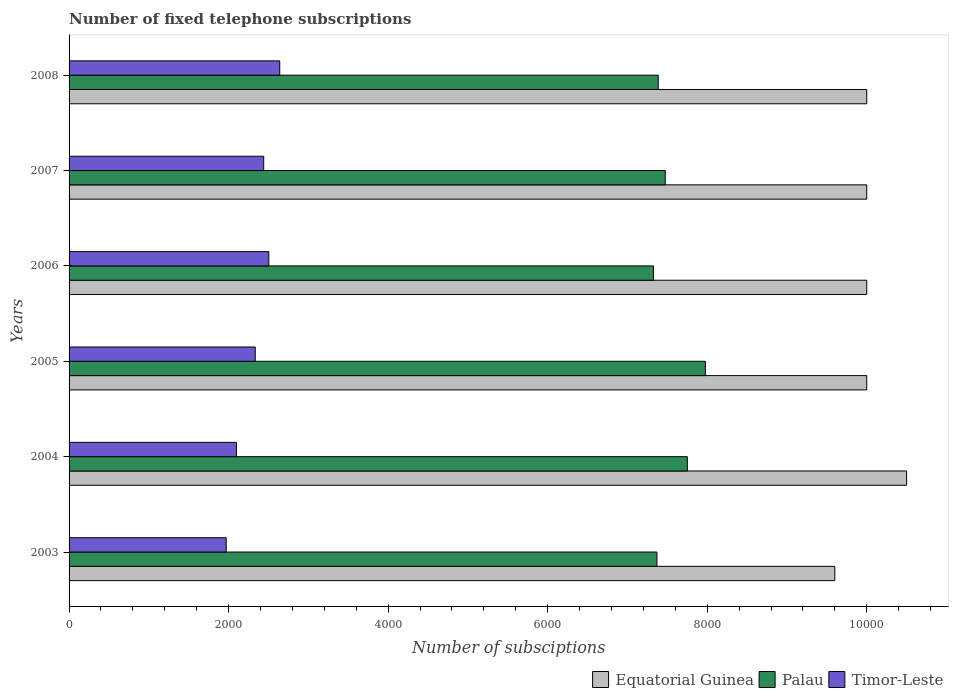How many different coloured bars are there?
Provide a succinct answer. 3. Are the number of bars per tick equal to the number of legend labels?
Your answer should be compact. Yes. Are the number of bars on each tick of the Y-axis equal?
Provide a short and direct response. Yes. How many bars are there on the 4th tick from the top?
Offer a very short reply. 3. What is the label of the 5th group of bars from the top?
Keep it short and to the point. 2004. In how many cases, is the number of bars for a given year not equal to the number of legend labels?
Your response must be concise. 0. What is the number of fixed telephone subscriptions in Equatorial Guinea in 2004?
Your answer should be very brief. 1.05e+04. Across all years, what is the maximum number of fixed telephone subscriptions in Palau?
Offer a terse response. 7977. Across all years, what is the minimum number of fixed telephone subscriptions in Timor-Leste?
Ensure brevity in your answer.  1970. What is the total number of fixed telephone subscriptions in Timor-Leste in the graph?
Your answer should be very brief. 1.40e+04. What is the difference between the number of fixed telephone subscriptions in Equatorial Guinea in 2007 and that in 2008?
Provide a succinct answer. 0. What is the difference between the number of fixed telephone subscriptions in Timor-Leste in 2006 and the number of fixed telephone subscriptions in Equatorial Guinea in 2007?
Your answer should be compact. -7496. What is the average number of fixed telephone subscriptions in Equatorial Guinea per year?
Offer a very short reply. 1.00e+04. In the year 2003, what is the difference between the number of fixed telephone subscriptions in Equatorial Guinea and number of fixed telephone subscriptions in Timor-Leste?
Offer a terse response. 7630. In how many years, is the number of fixed telephone subscriptions in Equatorial Guinea greater than 7600 ?
Your answer should be compact. 6. What is the difference between the highest and the second highest number of fixed telephone subscriptions in Palau?
Offer a terse response. 226. What is the difference between the highest and the lowest number of fixed telephone subscriptions in Timor-Leste?
Provide a succinct answer. 671. What does the 2nd bar from the top in 2006 represents?
Your answer should be very brief. Palau. What does the 3rd bar from the bottom in 2005 represents?
Your answer should be very brief. Timor-Leste. Is it the case that in every year, the sum of the number of fixed telephone subscriptions in Palau and number of fixed telephone subscriptions in Equatorial Guinea is greater than the number of fixed telephone subscriptions in Timor-Leste?
Make the answer very short. Yes. Are all the bars in the graph horizontal?
Provide a short and direct response. Yes. What is the difference between two consecutive major ticks on the X-axis?
Your answer should be very brief. 2000. Are the values on the major ticks of X-axis written in scientific E-notation?
Give a very brief answer. No. Does the graph contain any zero values?
Provide a succinct answer. No. How many legend labels are there?
Keep it short and to the point. 3. How are the legend labels stacked?
Your response must be concise. Horizontal. What is the title of the graph?
Offer a terse response. Number of fixed telephone subscriptions. What is the label or title of the X-axis?
Keep it short and to the point. Number of subsciptions. What is the label or title of the Y-axis?
Provide a succinct answer. Years. What is the Number of subsciptions of Equatorial Guinea in 2003?
Keep it short and to the point. 9600. What is the Number of subsciptions in Palau in 2003?
Give a very brief answer. 7370. What is the Number of subsciptions in Timor-Leste in 2003?
Provide a succinct answer. 1970. What is the Number of subsciptions of Equatorial Guinea in 2004?
Provide a short and direct response. 1.05e+04. What is the Number of subsciptions in Palau in 2004?
Offer a terse response. 7751. What is the Number of subsciptions in Timor-Leste in 2004?
Provide a succinct answer. 2098. What is the Number of subsciptions of Equatorial Guinea in 2005?
Your answer should be very brief. 10000. What is the Number of subsciptions in Palau in 2005?
Offer a very short reply. 7977. What is the Number of subsciptions of Timor-Leste in 2005?
Provide a succinct answer. 2334. What is the Number of subsciptions in Equatorial Guinea in 2006?
Ensure brevity in your answer.  10000. What is the Number of subsciptions of Palau in 2006?
Offer a very short reply. 7326. What is the Number of subsciptions of Timor-Leste in 2006?
Provide a succinct answer. 2504. What is the Number of subsciptions of Palau in 2007?
Your response must be concise. 7474. What is the Number of subsciptions of Timor-Leste in 2007?
Your answer should be very brief. 2440. What is the Number of subsciptions of Equatorial Guinea in 2008?
Provide a short and direct response. 10000. What is the Number of subsciptions in Palau in 2008?
Offer a terse response. 7386. What is the Number of subsciptions of Timor-Leste in 2008?
Your answer should be very brief. 2641. Across all years, what is the maximum Number of subsciptions of Equatorial Guinea?
Make the answer very short. 1.05e+04. Across all years, what is the maximum Number of subsciptions of Palau?
Make the answer very short. 7977. Across all years, what is the maximum Number of subsciptions of Timor-Leste?
Ensure brevity in your answer.  2641. Across all years, what is the minimum Number of subsciptions in Equatorial Guinea?
Provide a short and direct response. 9600. Across all years, what is the minimum Number of subsciptions of Palau?
Offer a very short reply. 7326. Across all years, what is the minimum Number of subsciptions of Timor-Leste?
Ensure brevity in your answer.  1970. What is the total Number of subsciptions of Equatorial Guinea in the graph?
Offer a terse response. 6.01e+04. What is the total Number of subsciptions in Palau in the graph?
Your response must be concise. 4.53e+04. What is the total Number of subsciptions in Timor-Leste in the graph?
Offer a very short reply. 1.40e+04. What is the difference between the Number of subsciptions in Equatorial Guinea in 2003 and that in 2004?
Your response must be concise. -900. What is the difference between the Number of subsciptions in Palau in 2003 and that in 2004?
Provide a succinct answer. -381. What is the difference between the Number of subsciptions of Timor-Leste in 2003 and that in 2004?
Your answer should be compact. -128. What is the difference between the Number of subsciptions of Equatorial Guinea in 2003 and that in 2005?
Give a very brief answer. -400. What is the difference between the Number of subsciptions of Palau in 2003 and that in 2005?
Offer a terse response. -607. What is the difference between the Number of subsciptions of Timor-Leste in 2003 and that in 2005?
Provide a short and direct response. -364. What is the difference between the Number of subsciptions in Equatorial Guinea in 2003 and that in 2006?
Give a very brief answer. -400. What is the difference between the Number of subsciptions of Palau in 2003 and that in 2006?
Offer a terse response. 44. What is the difference between the Number of subsciptions of Timor-Leste in 2003 and that in 2006?
Your answer should be compact. -534. What is the difference between the Number of subsciptions of Equatorial Guinea in 2003 and that in 2007?
Ensure brevity in your answer.  -400. What is the difference between the Number of subsciptions of Palau in 2003 and that in 2007?
Offer a very short reply. -104. What is the difference between the Number of subsciptions of Timor-Leste in 2003 and that in 2007?
Keep it short and to the point. -470. What is the difference between the Number of subsciptions of Equatorial Guinea in 2003 and that in 2008?
Keep it short and to the point. -400. What is the difference between the Number of subsciptions of Timor-Leste in 2003 and that in 2008?
Your answer should be compact. -671. What is the difference between the Number of subsciptions of Equatorial Guinea in 2004 and that in 2005?
Give a very brief answer. 500. What is the difference between the Number of subsciptions of Palau in 2004 and that in 2005?
Your answer should be compact. -226. What is the difference between the Number of subsciptions in Timor-Leste in 2004 and that in 2005?
Provide a short and direct response. -236. What is the difference between the Number of subsciptions in Palau in 2004 and that in 2006?
Ensure brevity in your answer.  425. What is the difference between the Number of subsciptions of Timor-Leste in 2004 and that in 2006?
Provide a short and direct response. -406. What is the difference between the Number of subsciptions of Equatorial Guinea in 2004 and that in 2007?
Give a very brief answer. 500. What is the difference between the Number of subsciptions in Palau in 2004 and that in 2007?
Make the answer very short. 277. What is the difference between the Number of subsciptions in Timor-Leste in 2004 and that in 2007?
Offer a very short reply. -342. What is the difference between the Number of subsciptions in Equatorial Guinea in 2004 and that in 2008?
Provide a short and direct response. 500. What is the difference between the Number of subsciptions of Palau in 2004 and that in 2008?
Your answer should be compact. 365. What is the difference between the Number of subsciptions in Timor-Leste in 2004 and that in 2008?
Provide a succinct answer. -543. What is the difference between the Number of subsciptions in Equatorial Guinea in 2005 and that in 2006?
Provide a succinct answer. 0. What is the difference between the Number of subsciptions of Palau in 2005 and that in 2006?
Make the answer very short. 651. What is the difference between the Number of subsciptions in Timor-Leste in 2005 and that in 2006?
Provide a succinct answer. -170. What is the difference between the Number of subsciptions in Equatorial Guinea in 2005 and that in 2007?
Your answer should be very brief. 0. What is the difference between the Number of subsciptions in Palau in 2005 and that in 2007?
Your answer should be compact. 503. What is the difference between the Number of subsciptions of Timor-Leste in 2005 and that in 2007?
Offer a terse response. -106. What is the difference between the Number of subsciptions of Equatorial Guinea in 2005 and that in 2008?
Keep it short and to the point. 0. What is the difference between the Number of subsciptions of Palau in 2005 and that in 2008?
Give a very brief answer. 591. What is the difference between the Number of subsciptions of Timor-Leste in 2005 and that in 2008?
Make the answer very short. -307. What is the difference between the Number of subsciptions of Palau in 2006 and that in 2007?
Provide a succinct answer. -148. What is the difference between the Number of subsciptions in Timor-Leste in 2006 and that in 2007?
Your answer should be compact. 64. What is the difference between the Number of subsciptions of Equatorial Guinea in 2006 and that in 2008?
Make the answer very short. 0. What is the difference between the Number of subsciptions of Palau in 2006 and that in 2008?
Make the answer very short. -60. What is the difference between the Number of subsciptions of Timor-Leste in 2006 and that in 2008?
Offer a terse response. -137. What is the difference between the Number of subsciptions in Timor-Leste in 2007 and that in 2008?
Ensure brevity in your answer.  -201. What is the difference between the Number of subsciptions of Equatorial Guinea in 2003 and the Number of subsciptions of Palau in 2004?
Provide a short and direct response. 1849. What is the difference between the Number of subsciptions of Equatorial Guinea in 2003 and the Number of subsciptions of Timor-Leste in 2004?
Your answer should be compact. 7502. What is the difference between the Number of subsciptions in Palau in 2003 and the Number of subsciptions in Timor-Leste in 2004?
Keep it short and to the point. 5272. What is the difference between the Number of subsciptions in Equatorial Guinea in 2003 and the Number of subsciptions in Palau in 2005?
Make the answer very short. 1623. What is the difference between the Number of subsciptions of Equatorial Guinea in 2003 and the Number of subsciptions of Timor-Leste in 2005?
Your answer should be compact. 7266. What is the difference between the Number of subsciptions in Palau in 2003 and the Number of subsciptions in Timor-Leste in 2005?
Keep it short and to the point. 5036. What is the difference between the Number of subsciptions of Equatorial Guinea in 2003 and the Number of subsciptions of Palau in 2006?
Your response must be concise. 2274. What is the difference between the Number of subsciptions of Equatorial Guinea in 2003 and the Number of subsciptions of Timor-Leste in 2006?
Your answer should be compact. 7096. What is the difference between the Number of subsciptions of Palau in 2003 and the Number of subsciptions of Timor-Leste in 2006?
Your response must be concise. 4866. What is the difference between the Number of subsciptions of Equatorial Guinea in 2003 and the Number of subsciptions of Palau in 2007?
Provide a succinct answer. 2126. What is the difference between the Number of subsciptions in Equatorial Guinea in 2003 and the Number of subsciptions in Timor-Leste in 2007?
Keep it short and to the point. 7160. What is the difference between the Number of subsciptions in Palau in 2003 and the Number of subsciptions in Timor-Leste in 2007?
Your answer should be very brief. 4930. What is the difference between the Number of subsciptions of Equatorial Guinea in 2003 and the Number of subsciptions of Palau in 2008?
Offer a very short reply. 2214. What is the difference between the Number of subsciptions of Equatorial Guinea in 2003 and the Number of subsciptions of Timor-Leste in 2008?
Your answer should be very brief. 6959. What is the difference between the Number of subsciptions in Palau in 2003 and the Number of subsciptions in Timor-Leste in 2008?
Your answer should be very brief. 4729. What is the difference between the Number of subsciptions of Equatorial Guinea in 2004 and the Number of subsciptions of Palau in 2005?
Your answer should be very brief. 2523. What is the difference between the Number of subsciptions in Equatorial Guinea in 2004 and the Number of subsciptions in Timor-Leste in 2005?
Your answer should be compact. 8166. What is the difference between the Number of subsciptions in Palau in 2004 and the Number of subsciptions in Timor-Leste in 2005?
Provide a succinct answer. 5417. What is the difference between the Number of subsciptions in Equatorial Guinea in 2004 and the Number of subsciptions in Palau in 2006?
Offer a very short reply. 3174. What is the difference between the Number of subsciptions of Equatorial Guinea in 2004 and the Number of subsciptions of Timor-Leste in 2006?
Make the answer very short. 7996. What is the difference between the Number of subsciptions in Palau in 2004 and the Number of subsciptions in Timor-Leste in 2006?
Make the answer very short. 5247. What is the difference between the Number of subsciptions in Equatorial Guinea in 2004 and the Number of subsciptions in Palau in 2007?
Provide a short and direct response. 3026. What is the difference between the Number of subsciptions in Equatorial Guinea in 2004 and the Number of subsciptions in Timor-Leste in 2007?
Provide a succinct answer. 8060. What is the difference between the Number of subsciptions in Palau in 2004 and the Number of subsciptions in Timor-Leste in 2007?
Your response must be concise. 5311. What is the difference between the Number of subsciptions in Equatorial Guinea in 2004 and the Number of subsciptions in Palau in 2008?
Your answer should be compact. 3114. What is the difference between the Number of subsciptions in Equatorial Guinea in 2004 and the Number of subsciptions in Timor-Leste in 2008?
Give a very brief answer. 7859. What is the difference between the Number of subsciptions of Palau in 2004 and the Number of subsciptions of Timor-Leste in 2008?
Ensure brevity in your answer.  5110. What is the difference between the Number of subsciptions in Equatorial Guinea in 2005 and the Number of subsciptions in Palau in 2006?
Keep it short and to the point. 2674. What is the difference between the Number of subsciptions of Equatorial Guinea in 2005 and the Number of subsciptions of Timor-Leste in 2006?
Provide a short and direct response. 7496. What is the difference between the Number of subsciptions in Palau in 2005 and the Number of subsciptions in Timor-Leste in 2006?
Ensure brevity in your answer.  5473. What is the difference between the Number of subsciptions in Equatorial Guinea in 2005 and the Number of subsciptions in Palau in 2007?
Your answer should be very brief. 2526. What is the difference between the Number of subsciptions of Equatorial Guinea in 2005 and the Number of subsciptions of Timor-Leste in 2007?
Your answer should be compact. 7560. What is the difference between the Number of subsciptions of Palau in 2005 and the Number of subsciptions of Timor-Leste in 2007?
Make the answer very short. 5537. What is the difference between the Number of subsciptions in Equatorial Guinea in 2005 and the Number of subsciptions in Palau in 2008?
Give a very brief answer. 2614. What is the difference between the Number of subsciptions of Equatorial Guinea in 2005 and the Number of subsciptions of Timor-Leste in 2008?
Provide a short and direct response. 7359. What is the difference between the Number of subsciptions in Palau in 2005 and the Number of subsciptions in Timor-Leste in 2008?
Ensure brevity in your answer.  5336. What is the difference between the Number of subsciptions of Equatorial Guinea in 2006 and the Number of subsciptions of Palau in 2007?
Make the answer very short. 2526. What is the difference between the Number of subsciptions in Equatorial Guinea in 2006 and the Number of subsciptions in Timor-Leste in 2007?
Your answer should be very brief. 7560. What is the difference between the Number of subsciptions of Palau in 2006 and the Number of subsciptions of Timor-Leste in 2007?
Offer a terse response. 4886. What is the difference between the Number of subsciptions of Equatorial Guinea in 2006 and the Number of subsciptions of Palau in 2008?
Give a very brief answer. 2614. What is the difference between the Number of subsciptions in Equatorial Guinea in 2006 and the Number of subsciptions in Timor-Leste in 2008?
Keep it short and to the point. 7359. What is the difference between the Number of subsciptions of Palau in 2006 and the Number of subsciptions of Timor-Leste in 2008?
Offer a very short reply. 4685. What is the difference between the Number of subsciptions in Equatorial Guinea in 2007 and the Number of subsciptions in Palau in 2008?
Give a very brief answer. 2614. What is the difference between the Number of subsciptions in Equatorial Guinea in 2007 and the Number of subsciptions in Timor-Leste in 2008?
Offer a terse response. 7359. What is the difference between the Number of subsciptions of Palau in 2007 and the Number of subsciptions of Timor-Leste in 2008?
Provide a short and direct response. 4833. What is the average Number of subsciptions in Equatorial Guinea per year?
Offer a very short reply. 1.00e+04. What is the average Number of subsciptions in Palau per year?
Your response must be concise. 7547.33. What is the average Number of subsciptions in Timor-Leste per year?
Your answer should be very brief. 2331.17. In the year 2003, what is the difference between the Number of subsciptions in Equatorial Guinea and Number of subsciptions in Palau?
Your answer should be compact. 2230. In the year 2003, what is the difference between the Number of subsciptions in Equatorial Guinea and Number of subsciptions in Timor-Leste?
Your answer should be very brief. 7630. In the year 2003, what is the difference between the Number of subsciptions of Palau and Number of subsciptions of Timor-Leste?
Your answer should be compact. 5400. In the year 2004, what is the difference between the Number of subsciptions of Equatorial Guinea and Number of subsciptions of Palau?
Your response must be concise. 2749. In the year 2004, what is the difference between the Number of subsciptions of Equatorial Guinea and Number of subsciptions of Timor-Leste?
Your answer should be very brief. 8402. In the year 2004, what is the difference between the Number of subsciptions of Palau and Number of subsciptions of Timor-Leste?
Offer a terse response. 5653. In the year 2005, what is the difference between the Number of subsciptions in Equatorial Guinea and Number of subsciptions in Palau?
Ensure brevity in your answer.  2023. In the year 2005, what is the difference between the Number of subsciptions of Equatorial Guinea and Number of subsciptions of Timor-Leste?
Your response must be concise. 7666. In the year 2005, what is the difference between the Number of subsciptions in Palau and Number of subsciptions in Timor-Leste?
Ensure brevity in your answer.  5643. In the year 2006, what is the difference between the Number of subsciptions in Equatorial Guinea and Number of subsciptions in Palau?
Your answer should be very brief. 2674. In the year 2006, what is the difference between the Number of subsciptions of Equatorial Guinea and Number of subsciptions of Timor-Leste?
Your response must be concise. 7496. In the year 2006, what is the difference between the Number of subsciptions in Palau and Number of subsciptions in Timor-Leste?
Keep it short and to the point. 4822. In the year 2007, what is the difference between the Number of subsciptions in Equatorial Guinea and Number of subsciptions in Palau?
Keep it short and to the point. 2526. In the year 2007, what is the difference between the Number of subsciptions in Equatorial Guinea and Number of subsciptions in Timor-Leste?
Provide a short and direct response. 7560. In the year 2007, what is the difference between the Number of subsciptions of Palau and Number of subsciptions of Timor-Leste?
Your answer should be very brief. 5034. In the year 2008, what is the difference between the Number of subsciptions in Equatorial Guinea and Number of subsciptions in Palau?
Offer a very short reply. 2614. In the year 2008, what is the difference between the Number of subsciptions in Equatorial Guinea and Number of subsciptions in Timor-Leste?
Keep it short and to the point. 7359. In the year 2008, what is the difference between the Number of subsciptions in Palau and Number of subsciptions in Timor-Leste?
Make the answer very short. 4745. What is the ratio of the Number of subsciptions of Equatorial Guinea in 2003 to that in 2004?
Make the answer very short. 0.91. What is the ratio of the Number of subsciptions of Palau in 2003 to that in 2004?
Offer a very short reply. 0.95. What is the ratio of the Number of subsciptions of Timor-Leste in 2003 to that in 2004?
Your response must be concise. 0.94. What is the ratio of the Number of subsciptions in Palau in 2003 to that in 2005?
Offer a very short reply. 0.92. What is the ratio of the Number of subsciptions of Timor-Leste in 2003 to that in 2005?
Your answer should be very brief. 0.84. What is the ratio of the Number of subsciptions of Palau in 2003 to that in 2006?
Offer a very short reply. 1.01. What is the ratio of the Number of subsciptions in Timor-Leste in 2003 to that in 2006?
Your answer should be compact. 0.79. What is the ratio of the Number of subsciptions of Equatorial Guinea in 2003 to that in 2007?
Your answer should be compact. 0.96. What is the ratio of the Number of subsciptions of Palau in 2003 to that in 2007?
Provide a short and direct response. 0.99. What is the ratio of the Number of subsciptions of Timor-Leste in 2003 to that in 2007?
Give a very brief answer. 0.81. What is the ratio of the Number of subsciptions of Timor-Leste in 2003 to that in 2008?
Offer a terse response. 0.75. What is the ratio of the Number of subsciptions of Equatorial Guinea in 2004 to that in 2005?
Provide a short and direct response. 1.05. What is the ratio of the Number of subsciptions in Palau in 2004 to that in 2005?
Provide a short and direct response. 0.97. What is the ratio of the Number of subsciptions in Timor-Leste in 2004 to that in 2005?
Your answer should be compact. 0.9. What is the ratio of the Number of subsciptions of Palau in 2004 to that in 2006?
Give a very brief answer. 1.06. What is the ratio of the Number of subsciptions in Timor-Leste in 2004 to that in 2006?
Ensure brevity in your answer.  0.84. What is the ratio of the Number of subsciptions of Equatorial Guinea in 2004 to that in 2007?
Give a very brief answer. 1.05. What is the ratio of the Number of subsciptions of Palau in 2004 to that in 2007?
Make the answer very short. 1.04. What is the ratio of the Number of subsciptions in Timor-Leste in 2004 to that in 2007?
Offer a terse response. 0.86. What is the ratio of the Number of subsciptions of Equatorial Guinea in 2004 to that in 2008?
Your response must be concise. 1.05. What is the ratio of the Number of subsciptions in Palau in 2004 to that in 2008?
Offer a terse response. 1.05. What is the ratio of the Number of subsciptions in Timor-Leste in 2004 to that in 2008?
Ensure brevity in your answer.  0.79. What is the ratio of the Number of subsciptions in Equatorial Guinea in 2005 to that in 2006?
Offer a terse response. 1. What is the ratio of the Number of subsciptions in Palau in 2005 to that in 2006?
Your response must be concise. 1.09. What is the ratio of the Number of subsciptions of Timor-Leste in 2005 to that in 2006?
Your answer should be very brief. 0.93. What is the ratio of the Number of subsciptions of Palau in 2005 to that in 2007?
Make the answer very short. 1.07. What is the ratio of the Number of subsciptions of Timor-Leste in 2005 to that in 2007?
Provide a succinct answer. 0.96. What is the ratio of the Number of subsciptions in Palau in 2005 to that in 2008?
Your response must be concise. 1.08. What is the ratio of the Number of subsciptions of Timor-Leste in 2005 to that in 2008?
Provide a succinct answer. 0.88. What is the ratio of the Number of subsciptions in Palau in 2006 to that in 2007?
Provide a short and direct response. 0.98. What is the ratio of the Number of subsciptions in Timor-Leste in 2006 to that in 2007?
Offer a very short reply. 1.03. What is the ratio of the Number of subsciptions in Palau in 2006 to that in 2008?
Your answer should be compact. 0.99. What is the ratio of the Number of subsciptions in Timor-Leste in 2006 to that in 2008?
Give a very brief answer. 0.95. What is the ratio of the Number of subsciptions of Equatorial Guinea in 2007 to that in 2008?
Provide a succinct answer. 1. What is the ratio of the Number of subsciptions of Palau in 2007 to that in 2008?
Offer a terse response. 1.01. What is the ratio of the Number of subsciptions of Timor-Leste in 2007 to that in 2008?
Provide a short and direct response. 0.92. What is the difference between the highest and the second highest Number of subsciptions in Equatorial Guinea?
Make the answer very short. 500. What is the difference between the highest and the second highest Number of subsciptions in Palau?
Keep it short and to the point. 226. What is the difference between the highest and the second highest Number of subsciptions of Timor-Leste?
Offer a terse response. 137. What is the difference between the highest and the lowest Number of subsciptions of Equatorial Guinea?
Provide a short and direct response. 900. What is the difference between the highest and the lowest Number of subsciptions of Palau?
Your answer should be compact. 651. What is the difference between the highest and the lowest Number of subsciptions in Timor-Leste?
Offer a terse response. 671. 